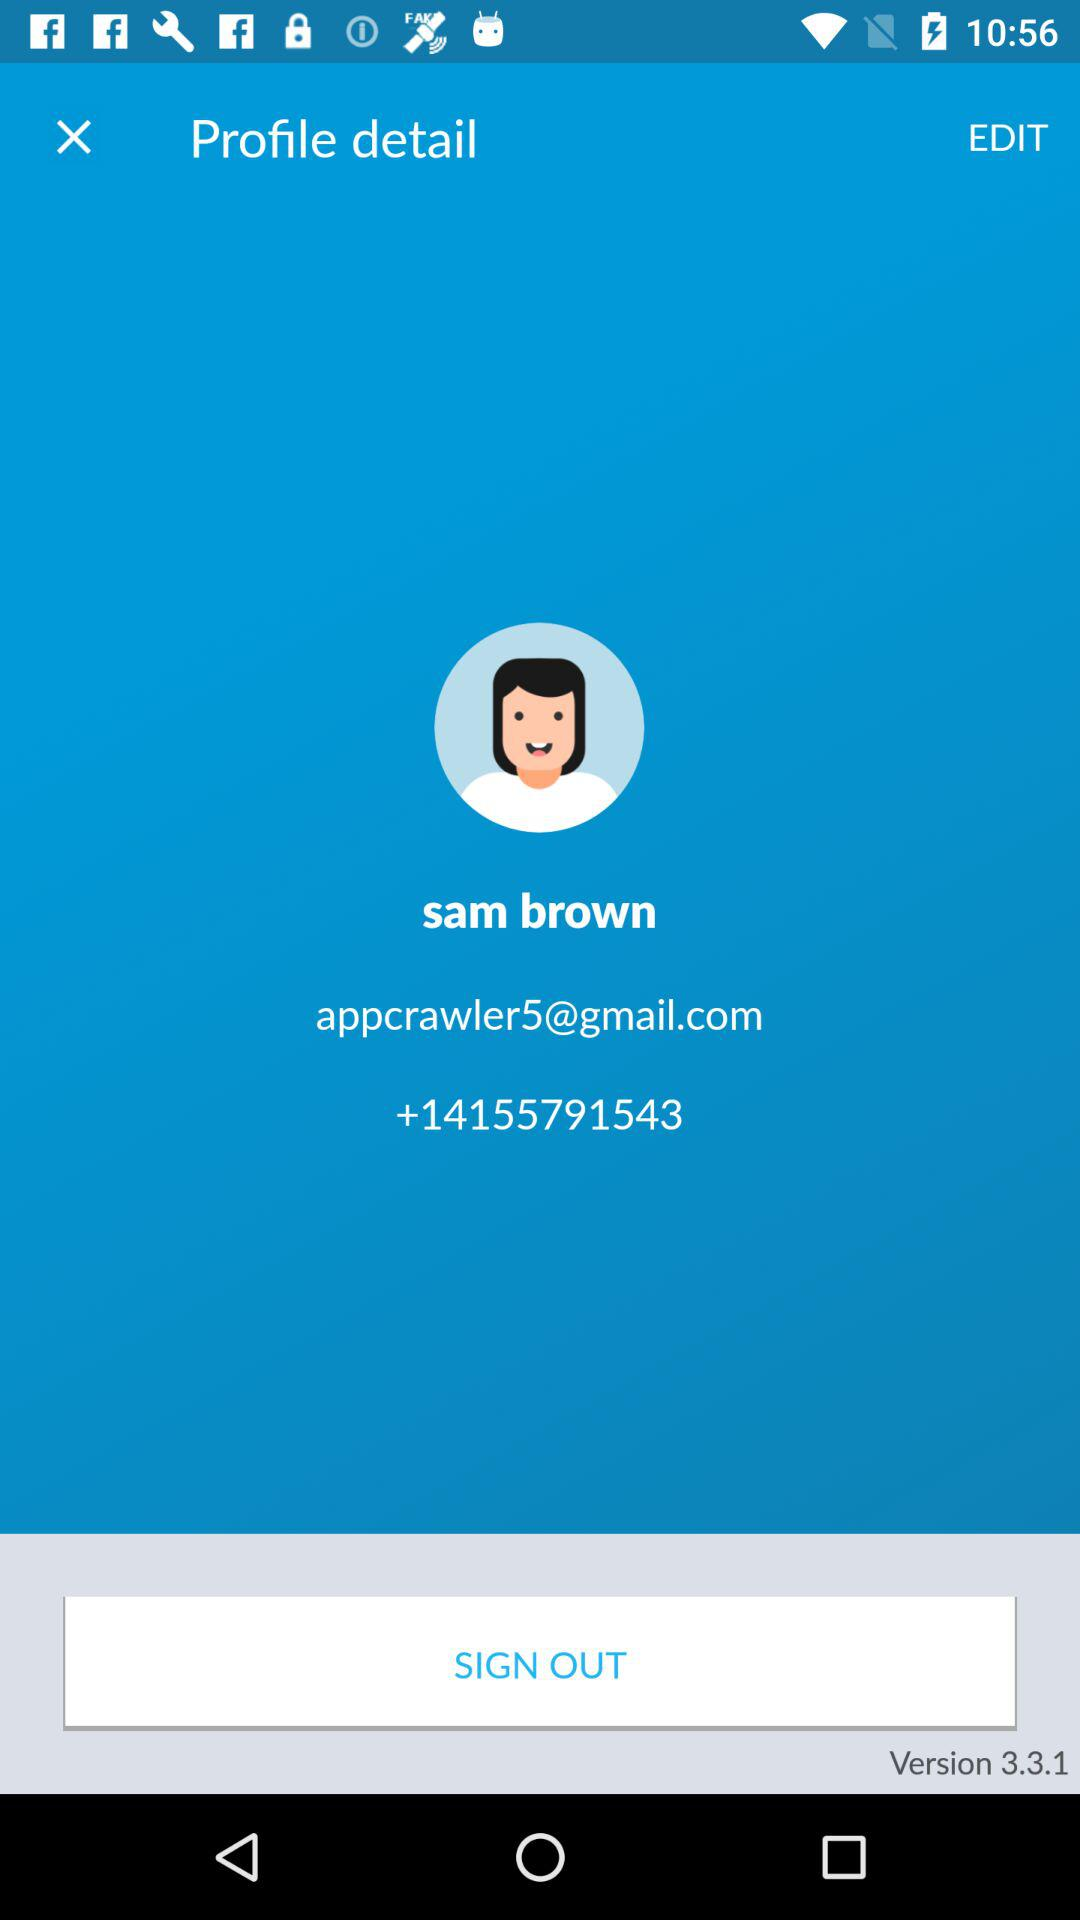What is the email address? The email address is appcrawler5@gmail.com. 